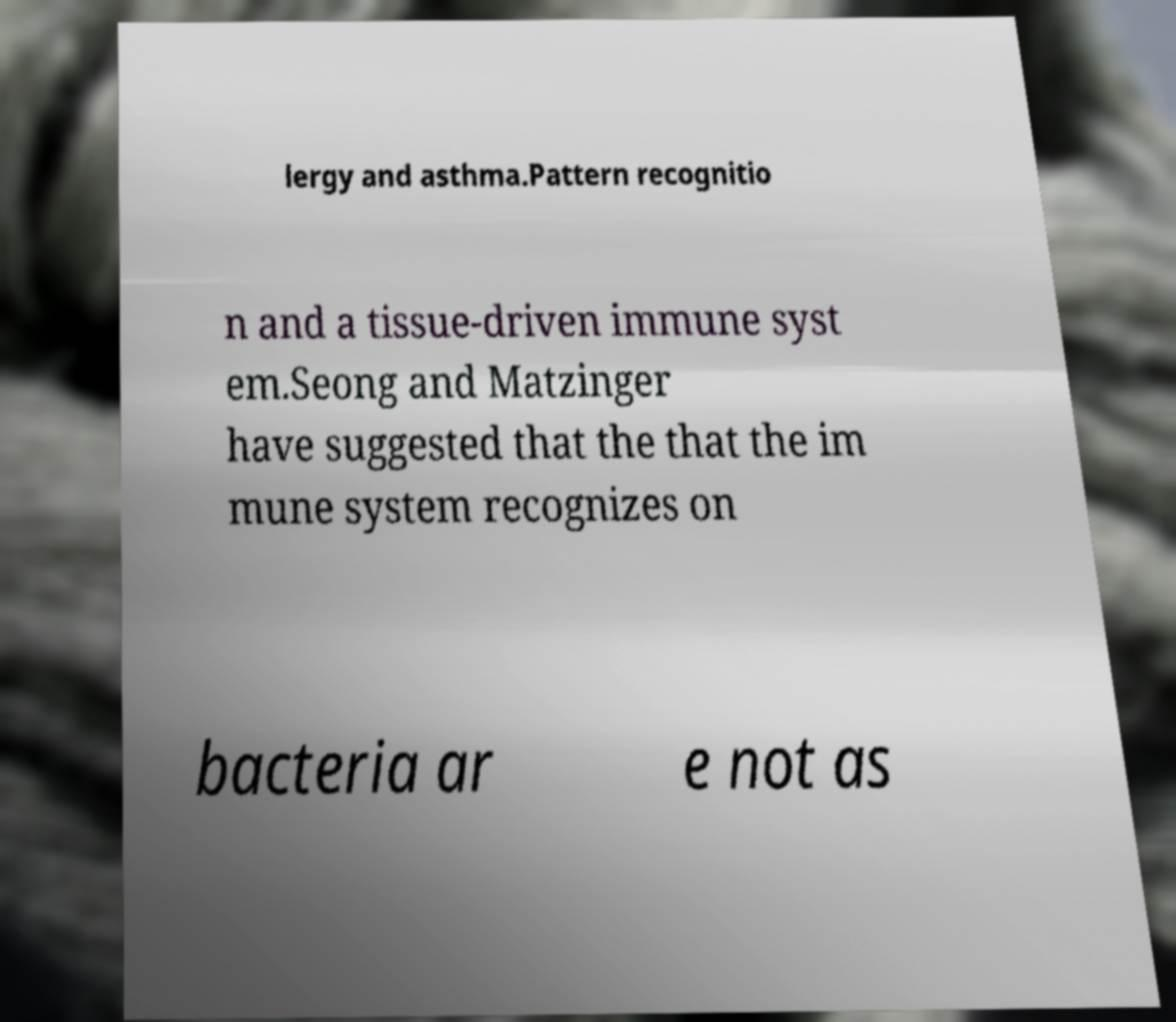I need the written content from this picture converted into text. Can you do that? lergy and asthma.Pattern recognitio n and a tissue-driven immune syst em.Seong and Matzinger have suggested that the that the im mune system recognizes on bacteria ar e not as 